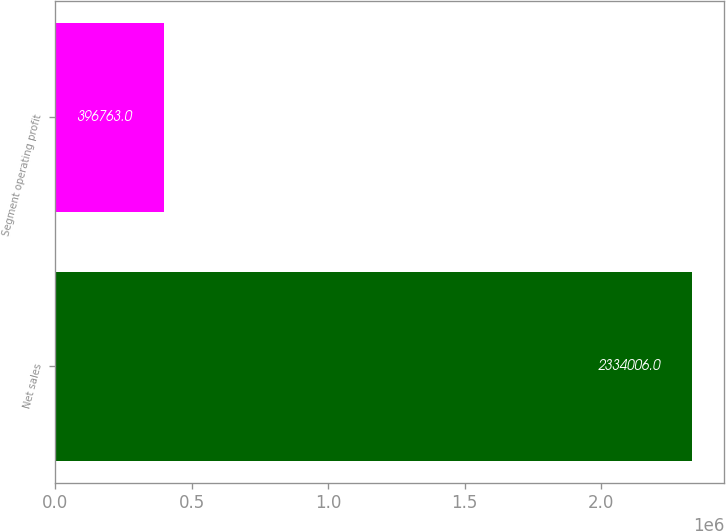<chart> <loc_0><loc_0><loc_500><loc_500><bar_chart><fcel>Net sales<fcel>Segment operating profit<nl><fcel>2.33401e+06<fcel>396763<nl></chart> 